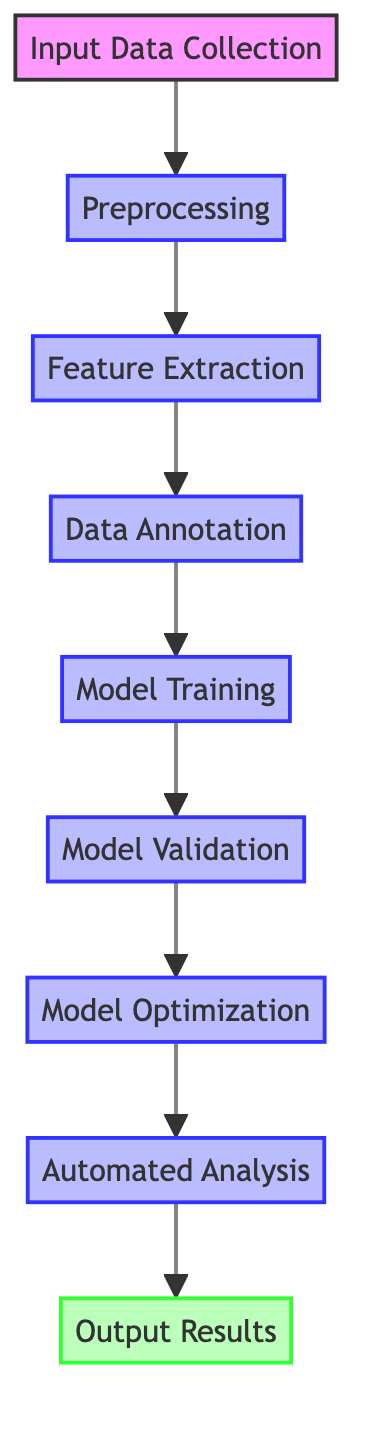What's the first node in the diagram? The diagram starts with the first node labeled "Input Data Collection," which is the initial step in the automated music analysis workflow.
Answer: Input Data Collection How many processes are in the workflow? Counting the nodes labeled with 'process', there are eight distinct processes depicted from "Preprocessing" to "Automated Analysis."
Answer: Eight What node comes after "Model Training"? Following "Model Training," the next node in the workflow is "Model Validation," which focuses on evaluating the trained model's performance.
Answer: Model Validation Which node is responsible for generating output results? The node designated for generating output results is "Output Results," which presents the analysis findings in various forms.
Answer: Output Results What step involves feature extraction from the input data? The step directly after "Preprocessing" that involves extracting musical features is "Feature Extraction," where complex harmonic structures are identified.
Answer: Feature Extraction What is needed before "Model Optimization" can occur? Before "Model Optimization" can take place, "Model Validation" must be successfully completed to ensure the model's accuracy and reliability.
Answer: Model Validation Which step requires human experts in music theory? The step that involves human experts in the field of music theory is "Data Annotation," where extracted features are labeled with relevant metadata.
Answer: Data Annotation How does "Automated Analysis" relate to "Model Optimization"? "Automated Analysis" is dependent on "Model Optimization," meaning that the model must be optimized before it can be deployed for analyzing new compositions.
Answer: Model Optimization What are the evaluation metrics mentioned for "Model Validation"? The evaluation metrics noted for assessing "Model Validation" include accuracy, F1-score, and confusion matrix for measuring the model's performance.
Answer: Accuracy, F1-score, confusion matrix 